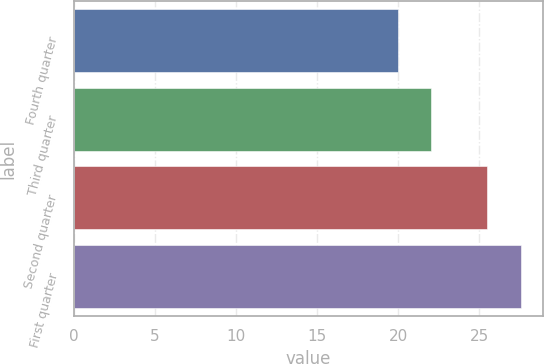Convert chart. <chart><loc_0><loc_0><loc_500><loc_500><bar_chart><fcel>Fourth quarter<fcel>Third quarter<fcel>Second quarter<fcel>First quarter<nl><fcel>20<fcel>22<fcel>25.45<fcel>27.55<nl></chart> 